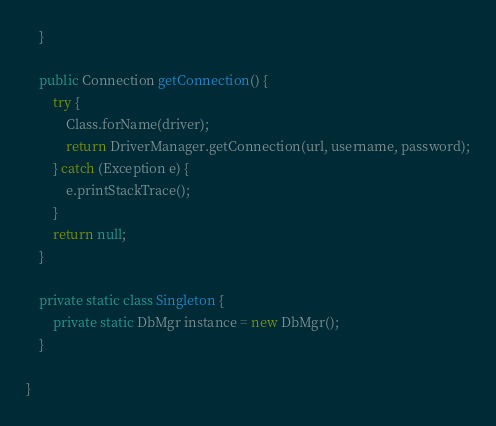<code> <loc_0><loc_0><loc_500><loc_500><_Java_>    }

    public Connection getConnection() {
        try {
            Class.forName(driver);
            return DriverManager.getConnection(url, username, password);
        } catch (Exception e) {
            e.printStackTrace();
        }
        return null;
    }

    private static class Singleton {
        private static DbMgr instance = new DbMgr();
    }

}
</code> 